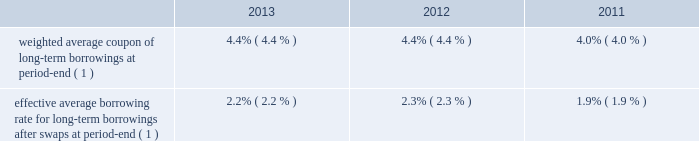Morgan stanley notes to consolidated financial statements 2014 ( continued ) consumer price index ) .
Senior debt also may be structured to be callable by the company or extendible at the option of holders of the senior debt securities .
Debt containing provisions that effectively allow the holders to put or extend the notes aggregated $ 1175 million at december 31 , 2013 and $ 1131 million at december 31 , 2012 .
In addition , separate agreements are entered into by the company 2019s subsidiaries that effectively allow the holders to put the notes aggregated $ 353 million at december 31 , 2013 and $ 1895 million at december 31 , 2012 .
Subordinated debt and junior subordinated debentures generally are issued to meet the capital requirements of the company or its regulated subsidiaries and primarily are u.s .
Dollar denominated .
Senior debt 2014structured borrowings .
The company 2019s index-linked , equity-linked or credit-linked borrowings include various structured instruments whose payments and redemption values are linked to the performance of a specific index ( e.g. , standard & poor 2019s 500 ) , a basket of stocks , a specific equity security , a credit exposure or basket of credit exposures .
To minimize the exposure resulting from movements in the underlying index , equity , credit or other position , the company has entered into various swap contracts and purchased options that effectively convert the borrowing costs into floating rates based upon libor .
These instruments are included in the preceding table at their redemption values based on the performance of the underlying indices , baskets of stocks , or specific equity securities , credit or other position or index .
The company carries either the entire structured borrowing at fair value or bifurcates the embedded derivative and carries it at fair value .
The swaps and purchased options used to economically hedge the embedded features are derivatives and also are carried at fair value .
Changes in fair value related to the notes and economic hedges are reported in trading revenues .
See note 4 for further information on structured borrowings .
Subordinated debt and junior subordinated debentures .
Included in the company 2019s long-term borrowings are subordinated notes of $ 9275 million having a contractual weighted average coupon of 4.69% ( 4.69 % ) at december 31 , 2013 and $ 5845 million having a weighted average coupon of 4.81% ( 4.81 % ) at december 31 , 2012 .
Junior subordinated debentures outstanding by the company were $ 4849 million at december 31 , 2013 and $ 4827 million at december 31 , 2012 having a contractual weighted average coupon of 6.37% ( 6.37 % ) at both december 31 , 2013 and december 31 , 2012 .
Maturities of the subordinated and junior subordinated notes range from 2014 to 2067 .
Maturities of certain junior subordinated debentures can be extended to 2052 at the company 2019s option .
Asset and liability management .
In general , securities inventories that are not financed by secured funding sources and the majority of the company 2019s assets are financed with a combination of deposits , short-term funding , floating rate long-term debt or fixed rate long-term debt swapped to a floating rate .
Fixed assets are generally financed with fixed rate long-term debt .
The company uses interest rate swaps to more closely match these borrowings to the duration , holding period and interest rate characteristics of the assets being funded and to manage interest rate risk .
These swaps effectively convert certain of the company 2019s fixed rate borrowings into floating rate obligations .
In addition , for non-u.s .
Dollar currency borrowings that are not used to fund assets in the same currency , the company has entered into currency swaps that effectively convert the borrowings into u.s .
Dollar obligations .
The company 2019s use of swaps for asset and liability management affected its effective average borrowing rate as follows: .
( 1 ) included in the weighted average and effective average calculations are non-u.s .
Dollar interest rates .
Other .
The company , through several of its subsidiaries , maintains funded and unfunded committed credit facilities to support various businesses , including the collateralized commercial and residential mortgage whole loan , derivative contracts , warehouse lending , emerging market loan , structured product , corporate loan , investment banking and prime brokerage businesses. .
What was the effect in difference of average borrowing rate due to the use of swaps in 2012? 
Computations: (4.4 - 2.3)
Answer: 2.1. 